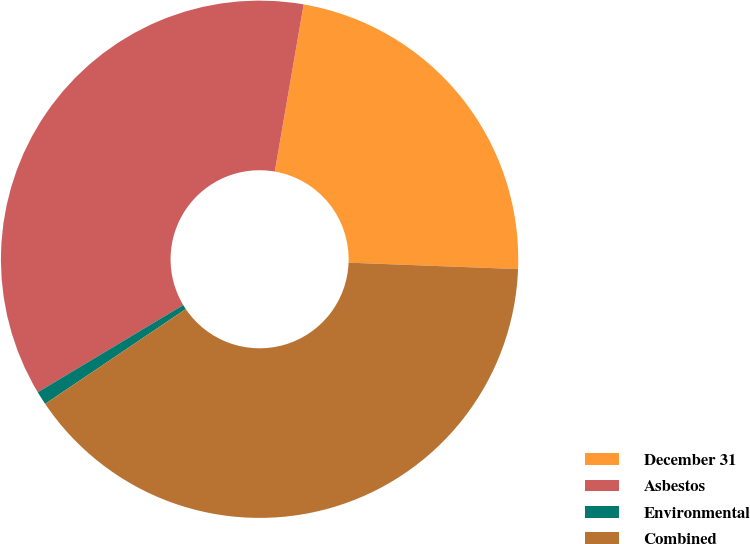<chart> <loc_0><loc_0><loc_500><loc_500><pie_chart><fcel>December 31<fcel>Asbestos<fcel>Environmental<fcel>Combined<nl><fcel>22.88%<fcel>36.32%<fcel>0.85%<fcel>39.95%<nl></chart> 